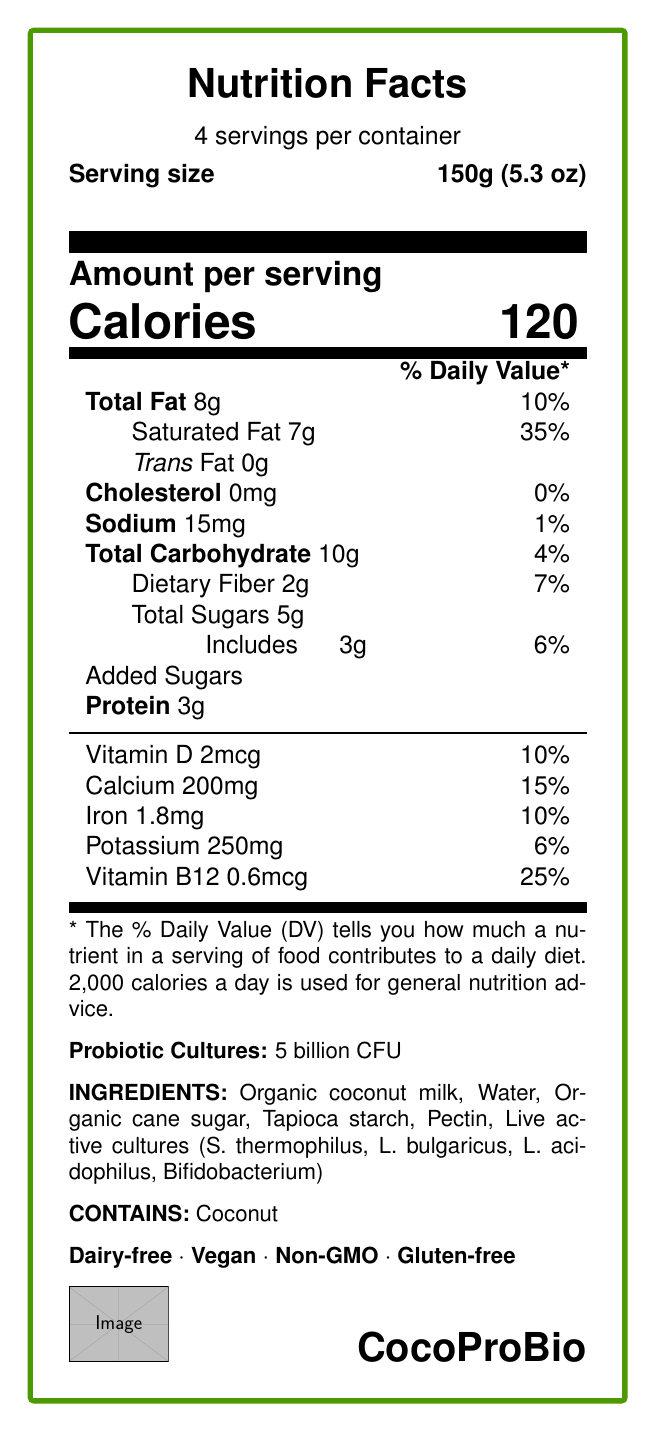what is the serving size? The serving size is clearly listed at the beginning of the Nutrition Facts section.
Answer: 150g (5.3 oz) how many servings are in each container? The Nutrition Facts label states there are 4 servings per container.
Answer: 4 what is the amount of protein per serving? The amount of protein per serving is listed in the Nutrition Facts section.
Answer: 3g what are the main ingredients? The main ingredients are listed towards the end of the document.
Answer: Organic coconut milk, Water, Organic cane sugar, Tapioca starch, Pectin, Live active cultures (S. thermophilus, L. bulgaricus, L. acidophilus, Bifidobacterium) what is the allergen information? The allergen information is stated clearly in the document.
Answer: Contains: Coconut how many calories are in one serving of CocoProBio? The calorie count per serving is prominently displayed in the Nutrition Facts section.
Answer: 120 how much saturated fat does one serving contain? The amount of saturated fat per serving is listed as 7g in the Nutrition Facts section.
Answer: 7g what percentage of the Daily Value is provided by the calcium content per serving? The percentage Daily Value for calcium is 15%, as mentioned in the Nutrition Facts section.
Answer: 15% how much dietary fiber is in one serving? The amount of dietary fiber per serving is 2g, according to the Nutrition Facts label.
Answer: 2g how much added sugar does the product contain per serving? The amount of added sugars per serving is listed as 3g in the document.
Answer: 3g which of the following health claims are made about CocoProBio? A. Dairy-free B. Contains artificial flavors C. Vegan D. Non-GMO E. Gluten-free The health claims are Dairy-free, Vegan, Non-GMO, and Gluten-free; no mention of containing artificial flavors.
Answer: A, C, D, E what is the main source of fat in this product? A. Olive oil B. Coconut milk C. Almond butter The main source of fat is coconut milk, as indicated by the ingredient list.
Answer: B does CocoProBio contain any cholesterol? The document lists cholesterol as 0mg per serving.
Answer: No is this product suitable for vegans? The document lists "Vegan" as one of its health claims.
Answer: Yes summarize the nutritional and health highlights of CocoProBio. The summary combines essential nutritional data and the health highlights dedicated to consumer benefits and sustainability.
Answer: CocoProBio is a probiotic-rich yogurt alternative made from organic coconut milk, offering 120 calories per serving. It is dairy-free, vegan, non-GMO, and gluten-free. Each serving provides 8g of total fat, including 7g of saturated fat, 3g of protein, and 2g of dietary fiber. CocoProBio offers notable amounts of calcium, vitamin D, iron, potassium, and vitamin B12, with 5 billion CFU of live active cultures for gut health. No artificial flavors or preservatives are used, and the packaging is made from 100% post-consumer recycled plastic. how many CFUs of probiotic cultures are in CocoProBio? The document states that each serving contains 5 billion CFU of probiotic cultures.
Answer: 5 billion CFU what is the price of this product? The price is not mentioned within the visual information of the Nutrition Facts Label.
Answer: Not enough information 